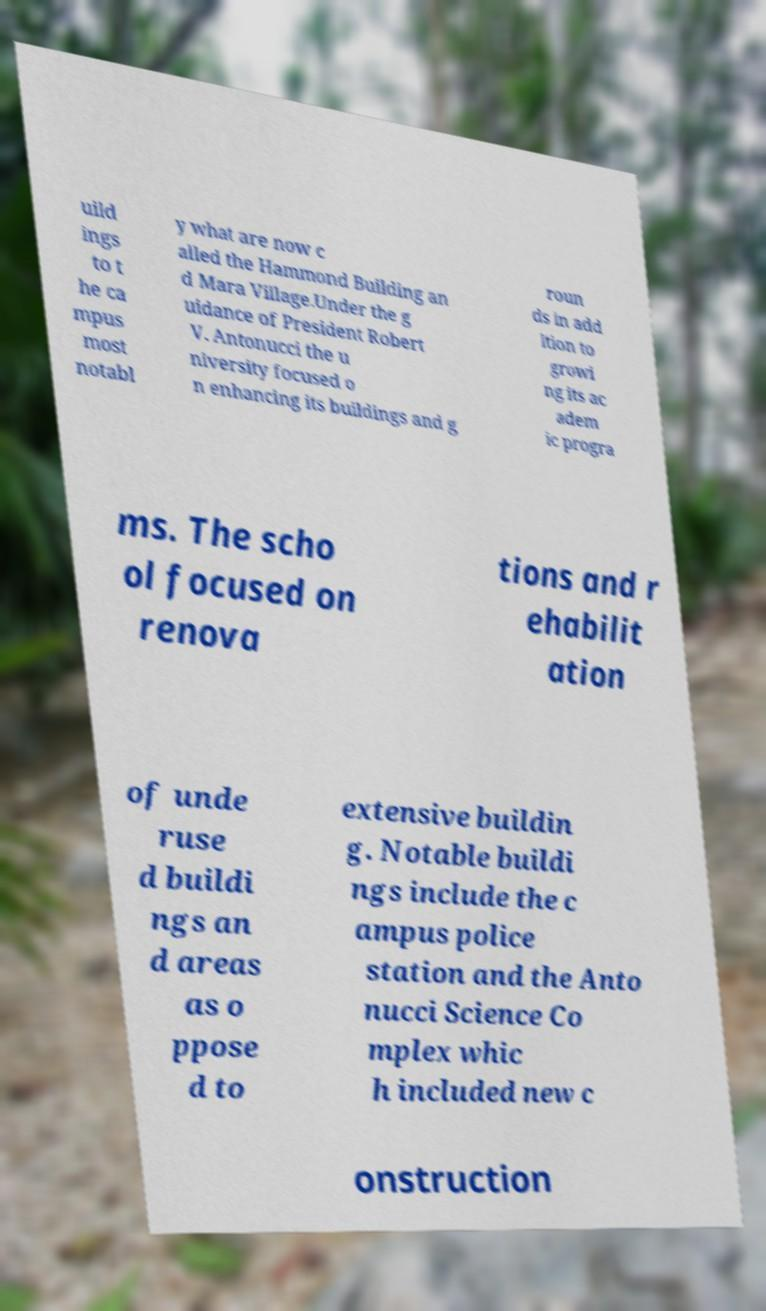What messages or text are displayed in this image? I need them in a readable, typed format. uild ings to t he ca mpus most notabl y what are now c alled the Hammond Building an d Mara Village.Under the g uidance of President Robert V. Antonucci the u niversity focused o n enhancing its buildings and g roun ds in add ition to growi ng its ac adem ic progra ms. The scho ol focused on renova tions and r ehabilit ation of unde ruse d buildi ngs an d areas as o ppose d to extensive buildin g. Notable buildi ngs include the c ampus police station and the Anto nucci Science Co mplex whic h included new c onstruction 